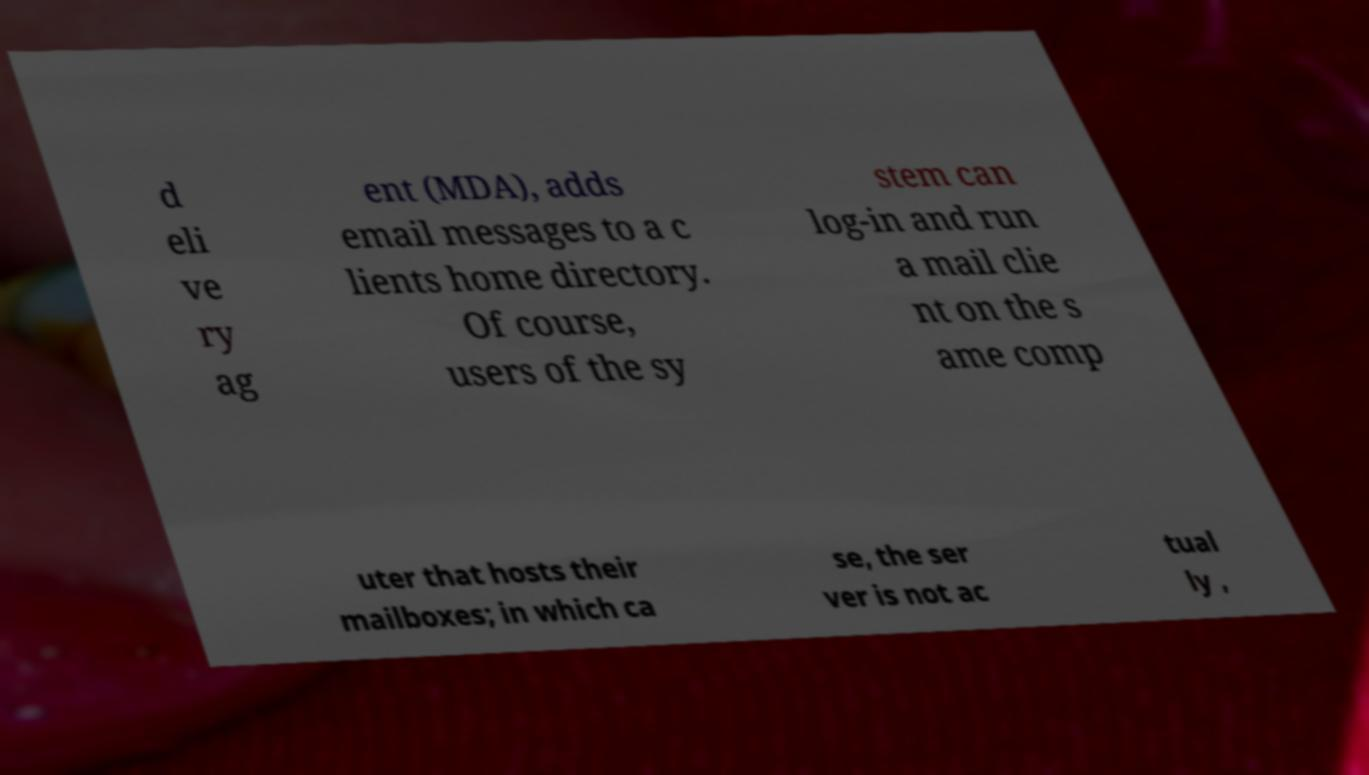Could you extract and type out the text from this image? d eli ve ry ag ent (MDA), adds email messages to a c lients home directory. Of course, users of the sy stem can log-in and run a mail clie nt on the s ame comp uter that hosts their mailboxes; in which ca se, the ser ver is not ac tual ly , 